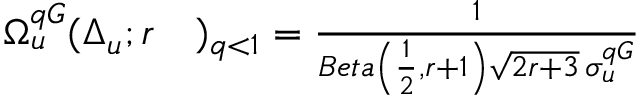Convert formula to latex. <formula><loc_0><loc_0><loc_500><loc_500>\begin{array} { r l } { \Omega _ { u } ^ { q G } ( \Delta _ { u } ; r } & ) _ { q < 1 } = \frac { 1 } { B e t a \left ( \frac { 1 } { 2 } , r + 1 \right ) \sqrt { 2 r + 3 } \, \sigma _ { u } ^ { q G } } } \end{array}</formula> 